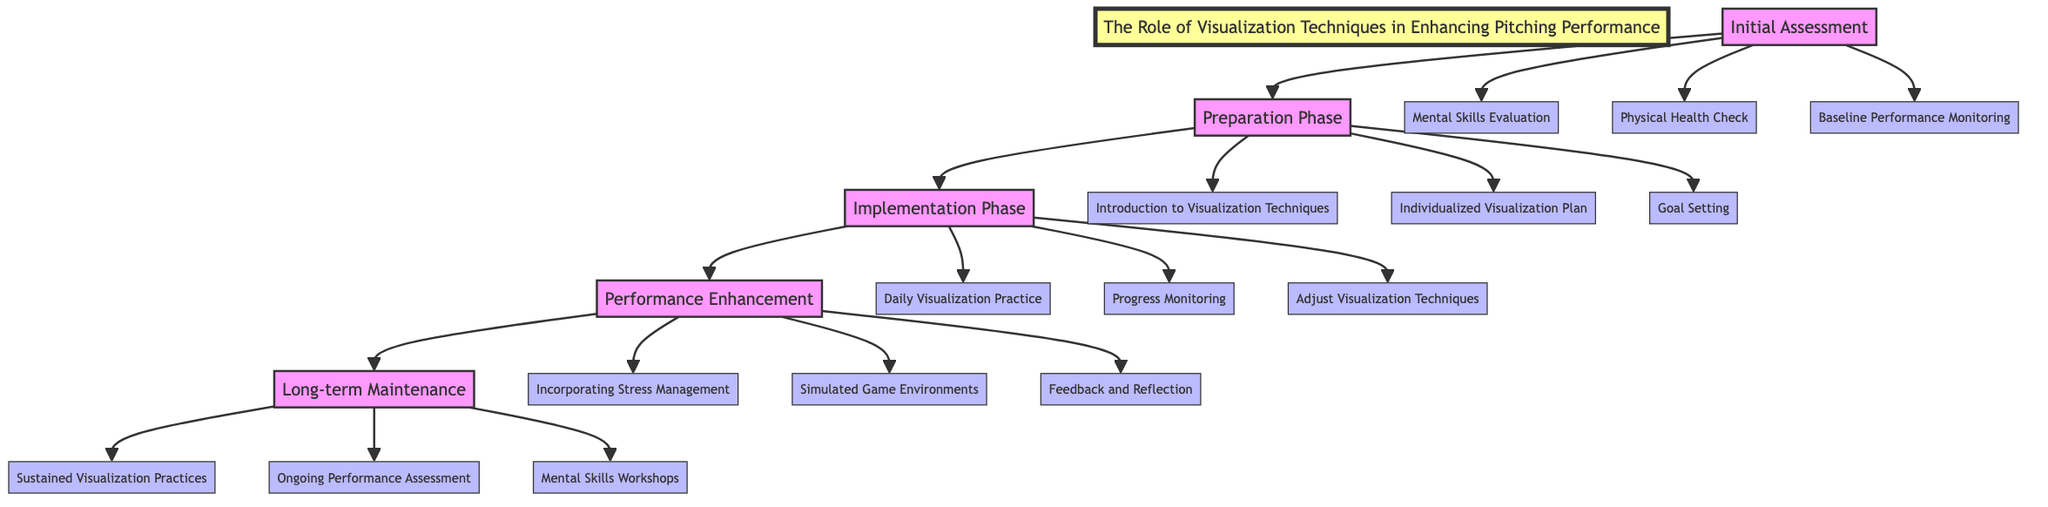What are the steps in the clinical pathway? The diagram outlines five steps: Initial Assessment, Preparation Phase, Implementation Phase, Performance Enhancement, and Long-term Maintenance. Each step is connected in a linear flow.
Answer: Initial Assessment, Preparation Phase, Implementation Phase, Performance Enhancement, Long-term Maintenance How many activities are included in the Performance Enhancement step? In the Performance Enhancement step, there are three activities: Incorporating Stress Management, Simulated Game Environments, and Feedback and Reflection. This can be counted directly from the connections stemming from this step.
Answer: 3 Which activity occurs after the Daily Visualization Practice? Following the Daily Visualization Practice, the next activity is Progress Monitoring, indicating a sequential process of visualization practice leading to performance assessment.
Answer: Progress Monitoring What is one of the goals set during the Preparation Phase? One goal set during the Preparation Phase is to establish specific, measurable, achievable, relevant, and time-bound (SMART) goals for visualization practices, showcasing the intention behind the preparation.
Answer: SMART goals Which step includes the activity of Mental Skills Evaluation? The Mental Skills Evaluation is found in the Initial Assessment step, which focuses on evaluating mental skills before moving into the preparation and implementation phases.
Answer: Initial Assessment What is the final step in this clinical pathway? The final step is Long-term Maintenance, emphasizing ongoing practices and assessments to ensure sustainable performance in pitching over time.
Answer: Long-term Maintenance What activity focuses on customizing visualization techniques? The Individualized Visualization Plan activity focuses on customizing visualization techniques tailored to the athlete's needs, directly addressing individual differences in training.
Answer: Individualized Visualization Plan How does the Implementation Phase progress? The Implementation Phase progresses through three activities: Daily Visualization Practice, which is followed by Progress Monitoring, and then Adjust Visualization Techniques, indicating a cycle of practice and evaluation.
Answer: Daily Visualization Practice, Progress Monitoring, Adjust Visualization Techniques 